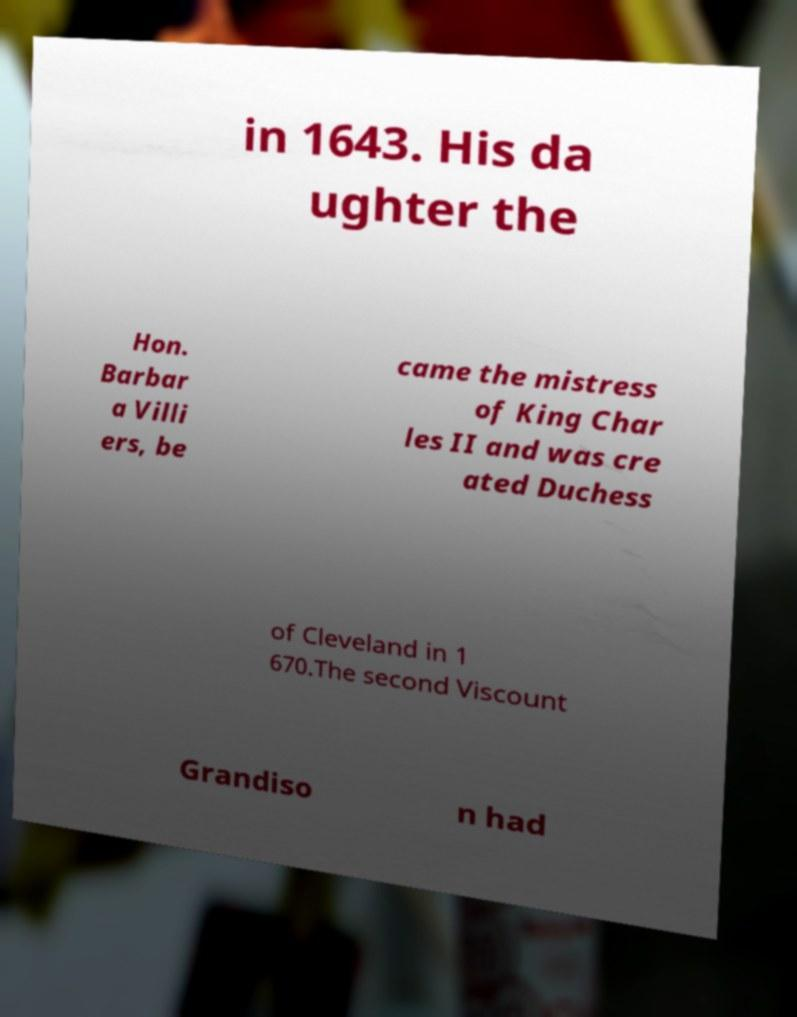What messages or text are displayed in this image? I need them in a readable, typed format. in 1643. His da ughter the Hon. Barbar a Villi ers, be came the mistress of King Char les II and was cre ated Duchess of Cleveland in 1 670.The second Viscount Grandiso n had 